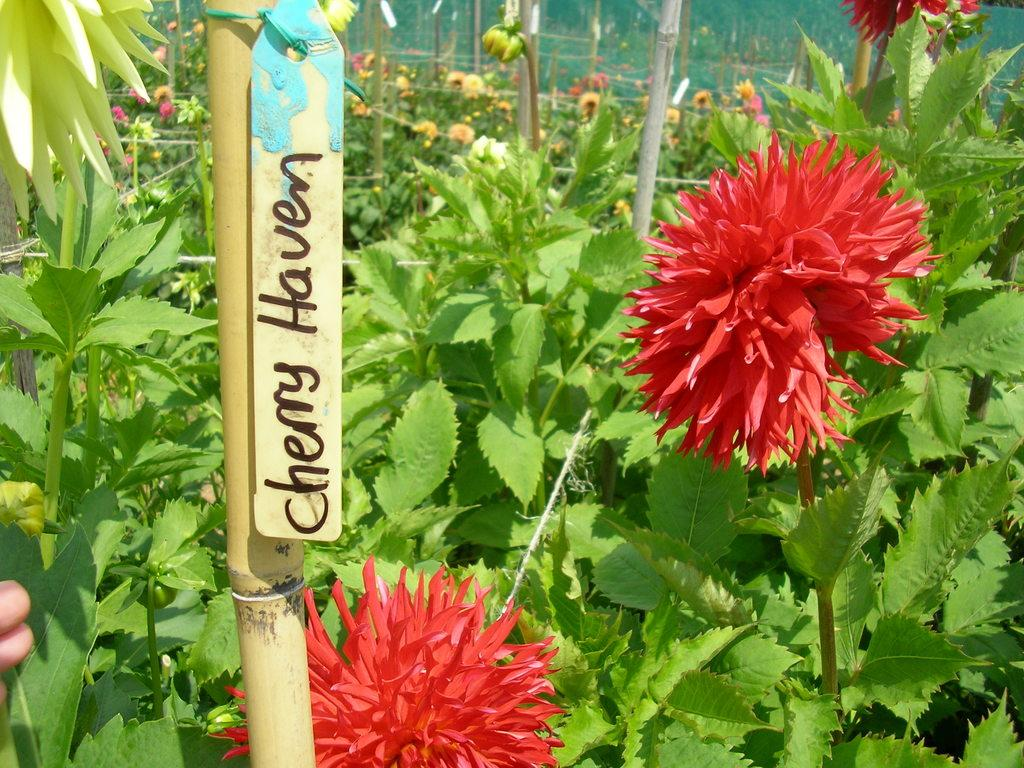What type of plants are visible in the image? There are plants with flowers in the image. What other objects can be seen in the image? There are sticks and a small board with text attached to a stick. Can you describe the board with text in the image? The board with text is attached to a stick. What part of a person can be seen in the image? A human hand is visible on the left side of the image. What type of basketball game is being played in the image? There is no basketball game present in the image. 